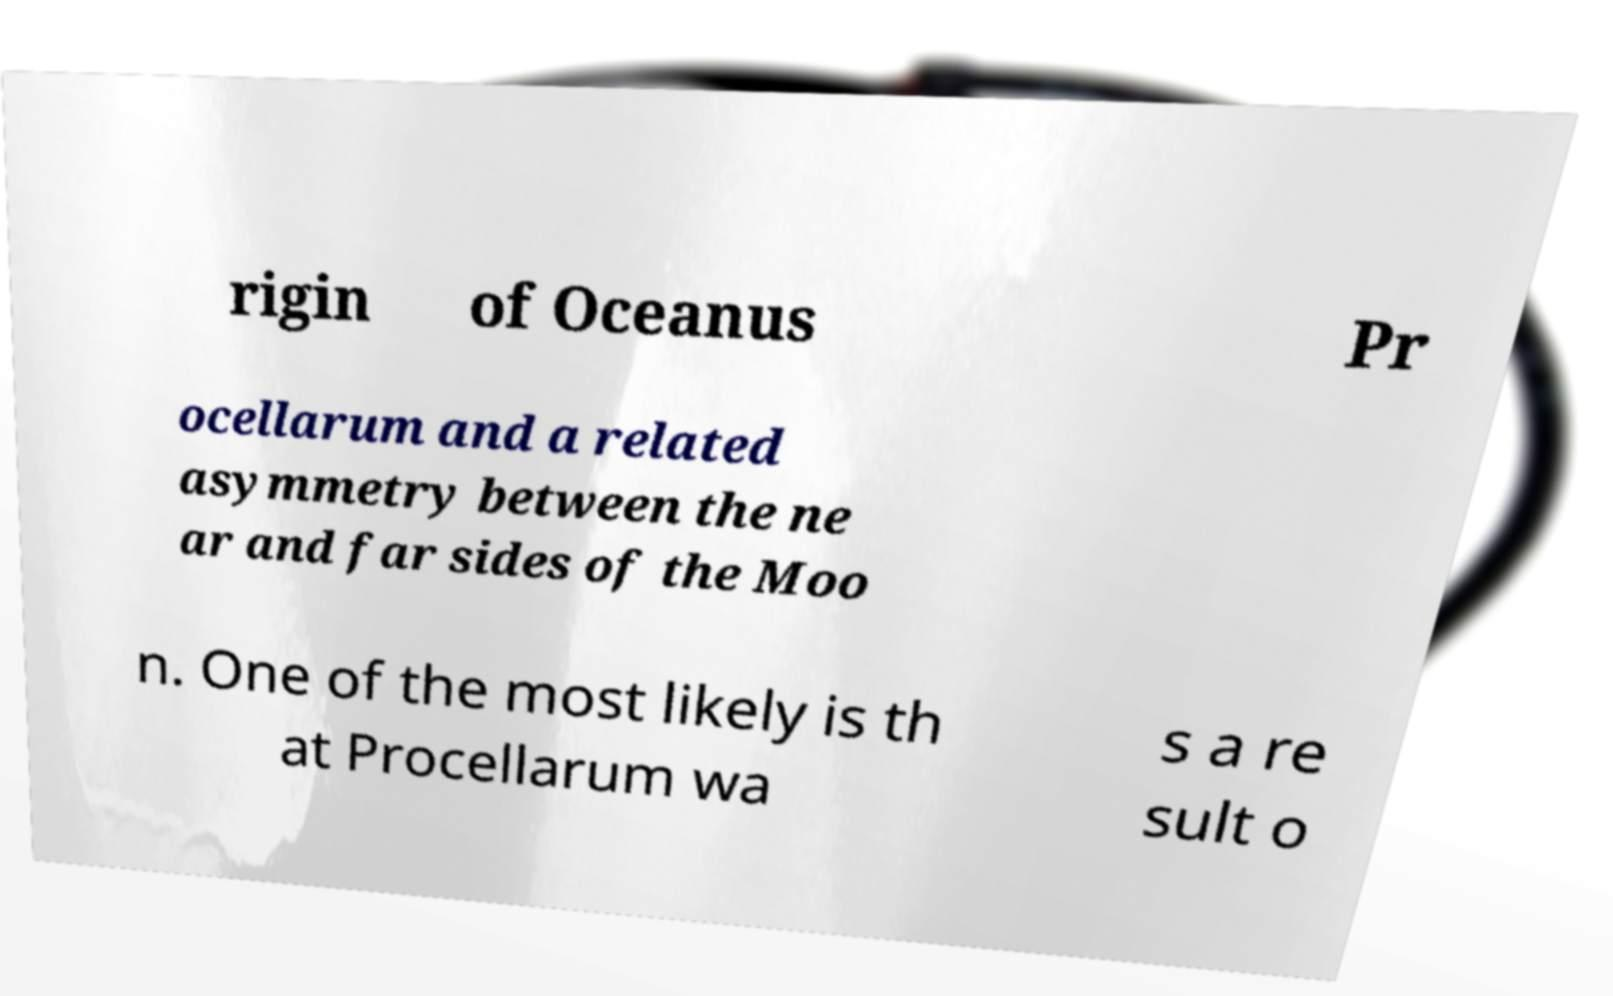Could you assist in decoding the text presented in this image and type it out clearly? rigin of Oceanus Pr ocellarum and a related asymmetry between the ne ar and far sides of the Moo n. One of the most likely is th at Procellarum wa s a re sult o 